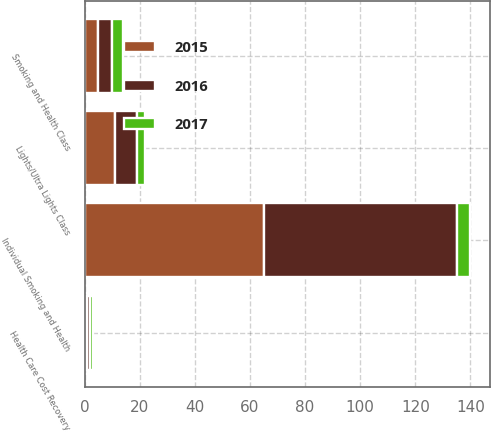Convert chart to OTSL. <chart><loc_0><loc_0><loc_500><loc_500><stacked_bar_chart><ecel><fcel>Individual Smoking and Health<fcel>Smoking and Health Class<fcel>Health Care Cost Recovery<fcel>Lights/Ultra Lights Class<nl><fcel>2017<fcel>5<fcel>4<fcel>1<fcel>3<nl><fcel>2016<fcel>70<fcel>5<fcel>1<fcel>8<nl><fcel>2015<fcel>65<fcel>5<fcel>1<fcel>11<nl></chart> 